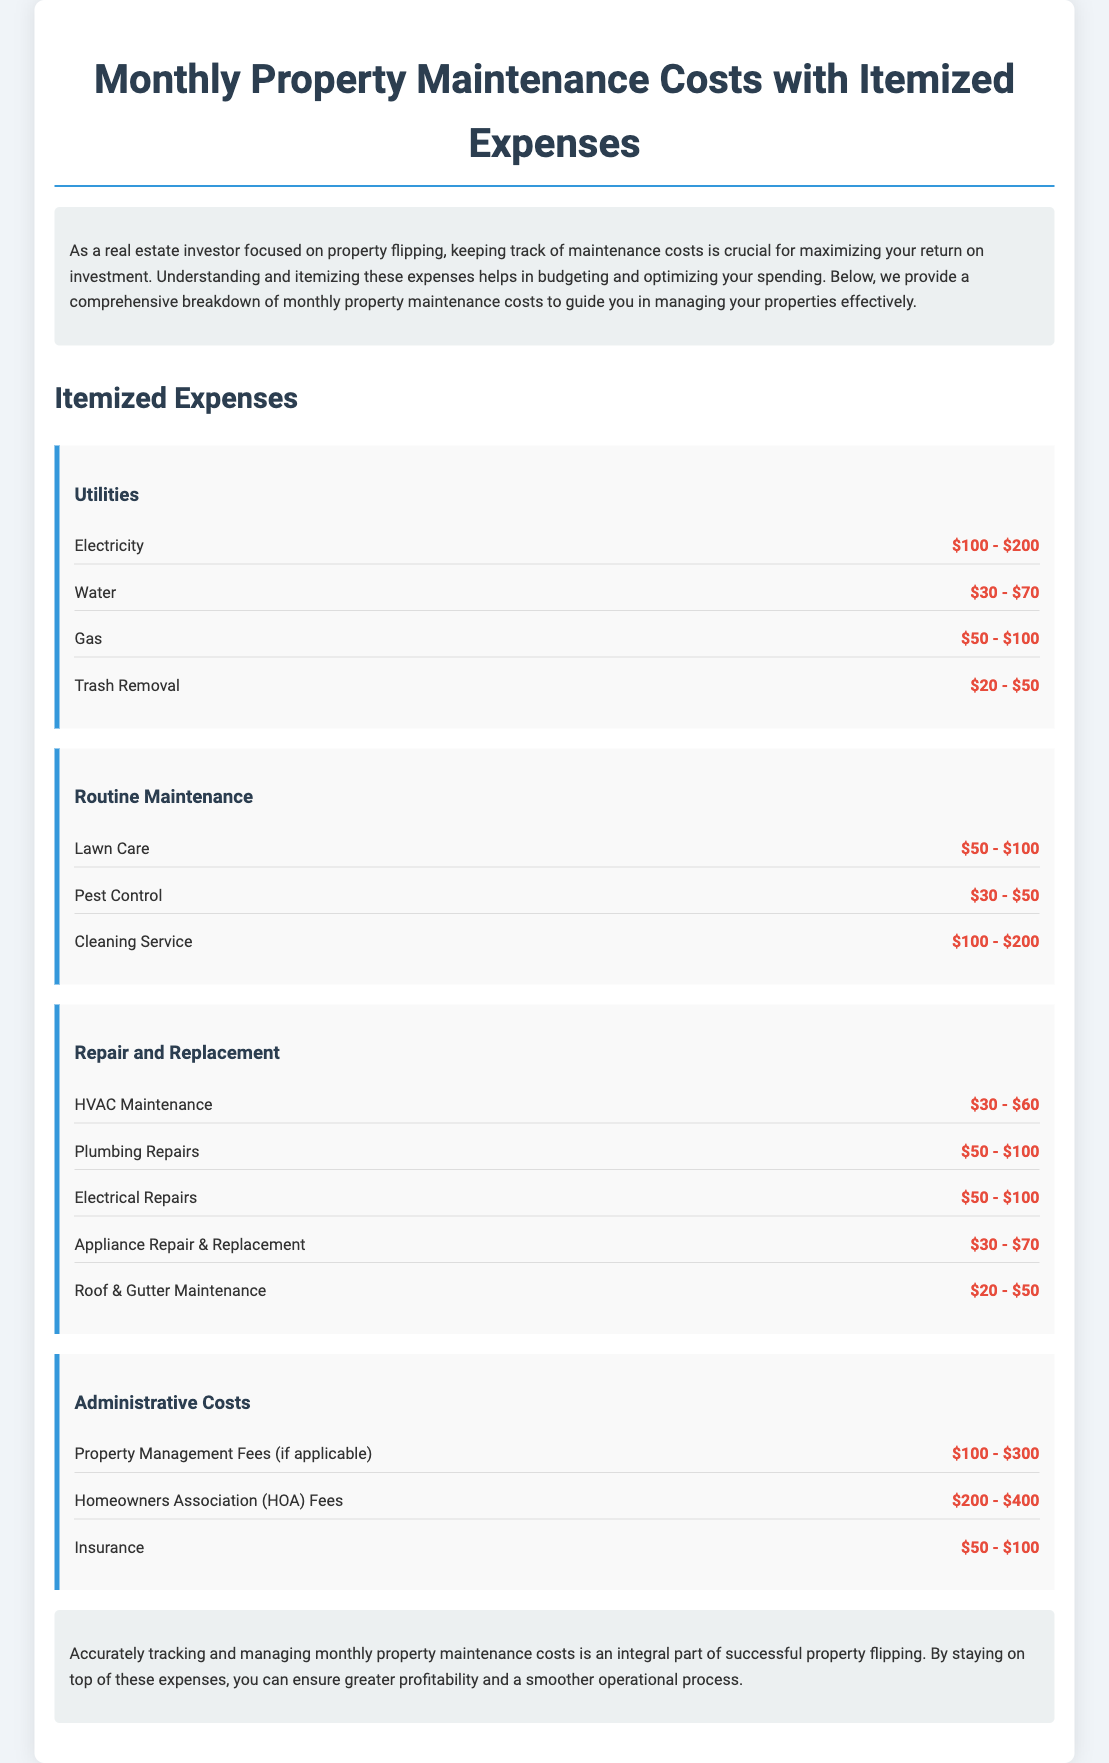what is the average cost of electricity? The average cost of electricity is calculated from the range given in the document, which is $100 - $200. The average would be $150.
Answer: $150 what is the cost range for plumbing repairs? The cost range for plumbing repairs is mentioned in the document.
Answer: $50 - $100 how much do homeowners association fees typically cost? The homeowners association fees in the document range from $200 to $400.
Answer: $200 - $400 which category includes lawn care? Lawn care is listed under the Routine Maintenance category in the document.
Answer: Routine Maintenance what are the total monthly administrative costs? The admin costs include property management fees, HOA fees, and insurance. Their ranges are $100 - $300, $200 - $400, and $50 - $100 respectively.
Answer: $350 - $800 what maintenance cost is least expensive according to the document? The least expensive maintenance cost mentioned is Roof & Gutter Maintenance, which ranges from $20 to $50.
Answer: $20 - $50 how much can trash removal cost at minimum? The document specifies the minimum cost for trash removal as $20.
Answer: $20 which maintenance costs are considered utilities? The document lists electricity, water, gas, and trash removal as utility costs.
Answer: Electricity, Water, Gas, Trash Removal what is the maximum expense for pest control? The document states the pest control cost ranges from $30 to $50, so the maximum expense is $50.
Answer: $50 